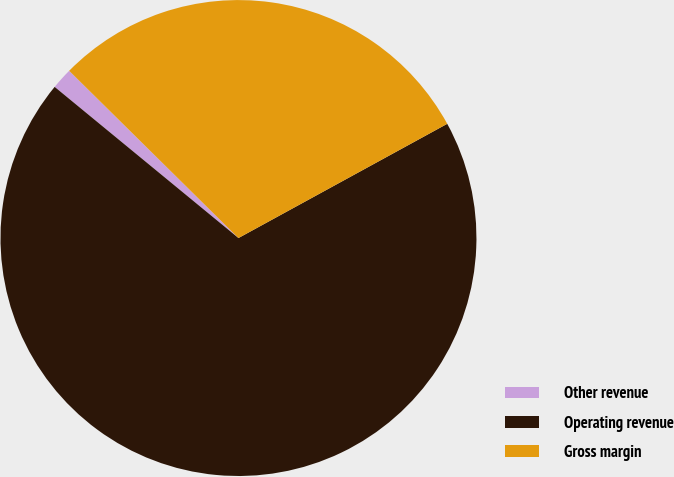<chart> <loc_0><loc_0><loc_500><loc_500><pie_chart><fcel>Other revenue<fcel>Operating revenue<fcel>Gross margin<nl><fcel>1.45%<fcel>68.92%<fcel>29.63%<nl></chart> 